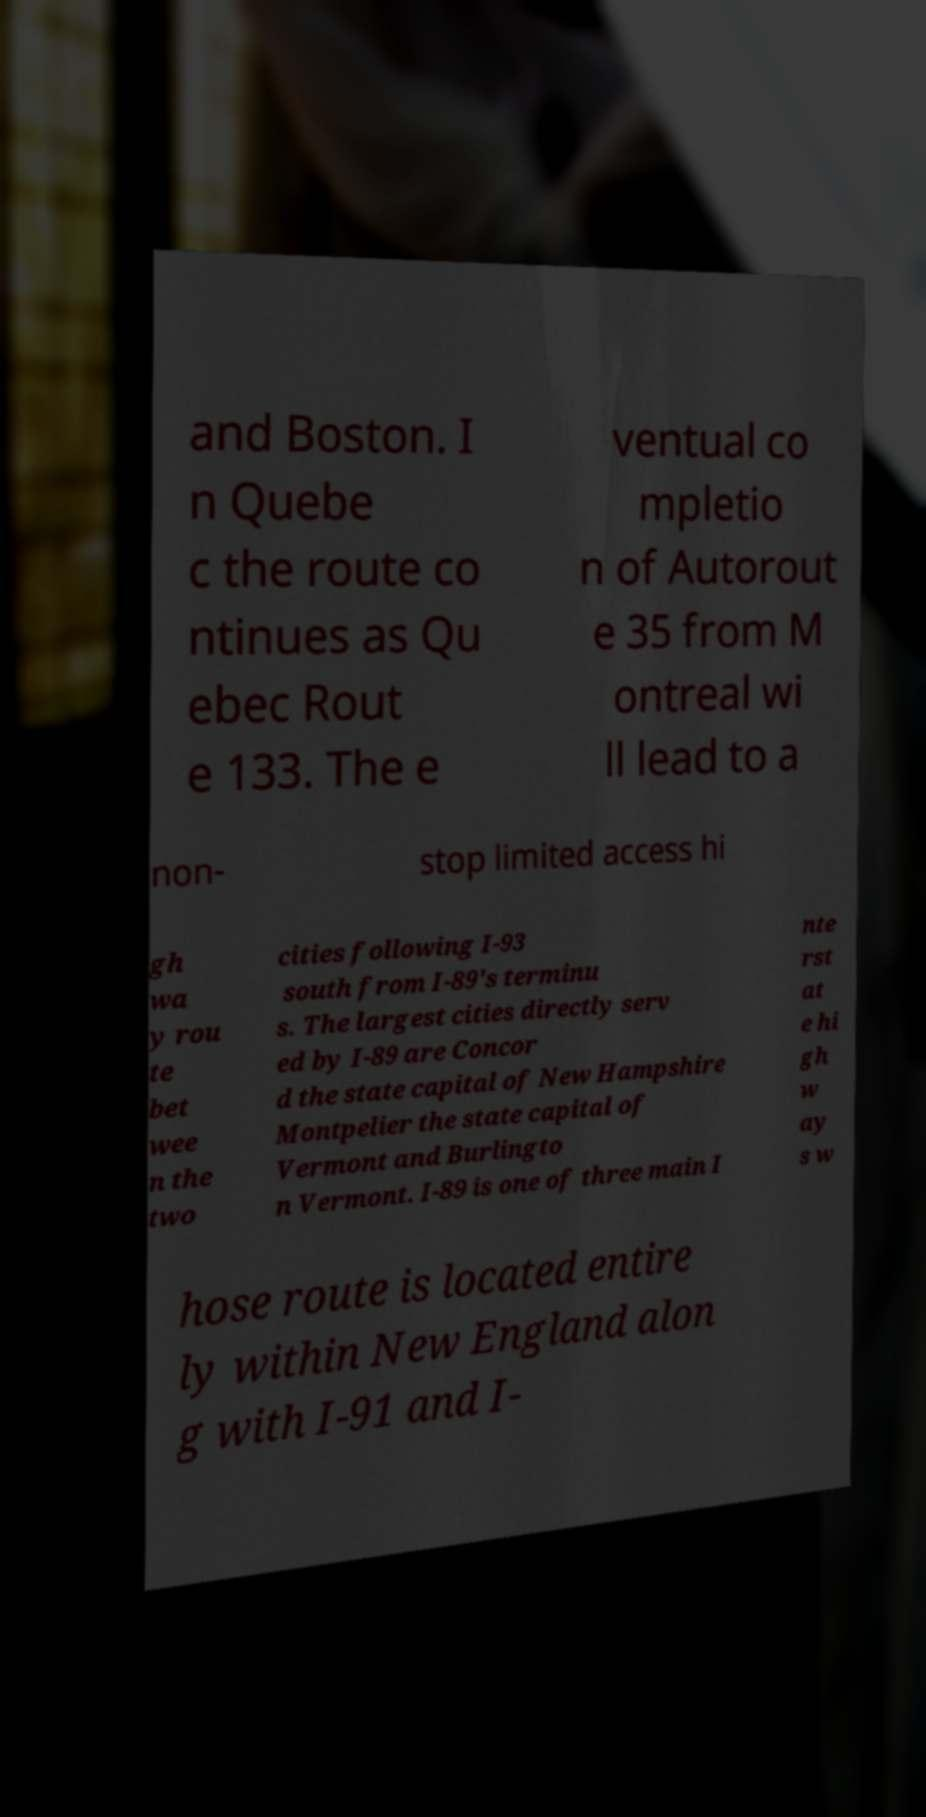There's text embedded in this image that I need extracted. Can you transcribe it verbatim? and Boston. I n Quebe c the route co ntinues as Qu ebec Rout e 133. The e ventual co mpletio n of Autorout e 35 from M ontreal wi ll lead to a non- stop limited access hi gh wa y rou te bet wee n the two cities following I-93 south from I-89's terminu s. The largest cities directly serv ed by I-89 are Concor d the state capital of New Hampshire Montpelier the state capital of Vermont and Burlingto n Vermont. I-89 is one of three main I nte rst at e hi gh w ay s w hose route is located entire ly within New England alon g with I-91 and I- 